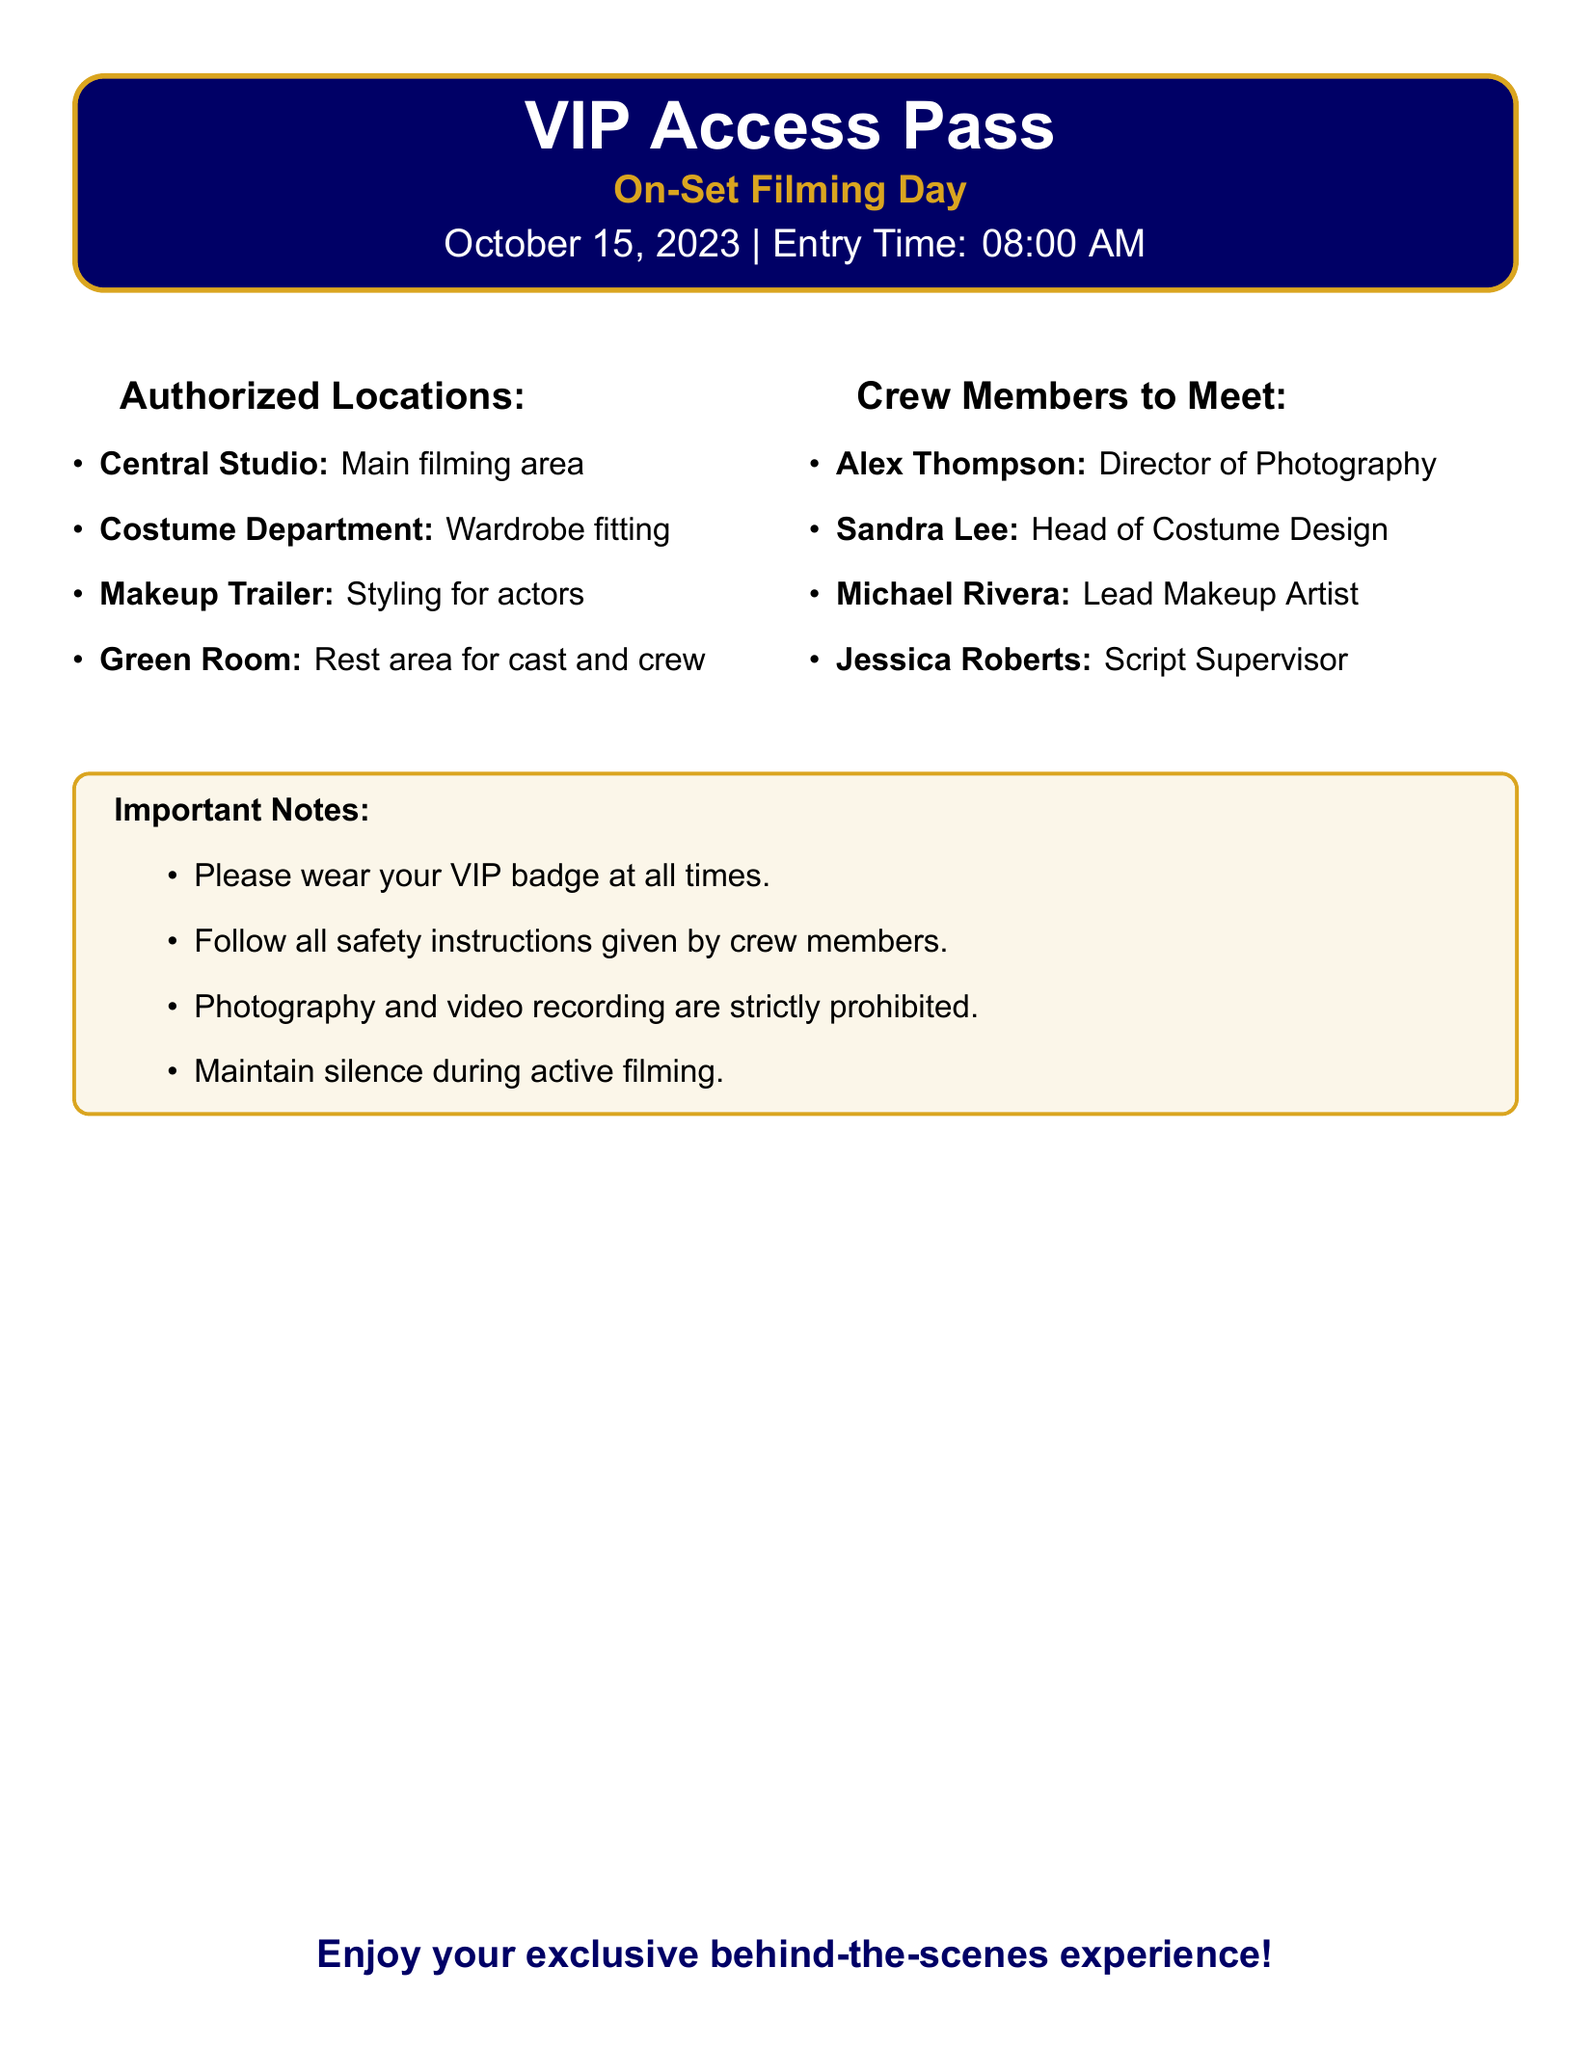What is the entry time for the event? The entry time is specified as 08:00 AM in the document.
Answer: 08:00 AM Which location is designated as the main filming area? The main filming area is listed as the Central Studio in the document.
Answer: Central Studio Who is the Director of Photography? The document states that Alex Thompson is the Director of Photography.
Answer: Alex Thompson Are photography and video recording allowed during the filming? The document clearly states that photography and video recording are strictly prohibited.
Answer: No What are the authorized locations one can access? The document lists four authorized locations for access: Central Studio, Costume Department, Makeup Trailer, and Green Room.
Answer: Central Studio, Costume Department, Makeup Trailer, Green Room Which crew member is responsible for costume design? The document mentions that Sandra Lee is the Head of Costume Design.
Answer: Sandra Lee What should you wear at all times? The document instructs to wear the VIP badge at all times.
Answer: VIP badge Is there a specific note about maintaining silence? Yes, the document notes to maintain silence during active filming.
Answer: Maintain silence during active filming How many crew members can you meet according to the document? The document lists four crew members available to meet.
Answer: Four 